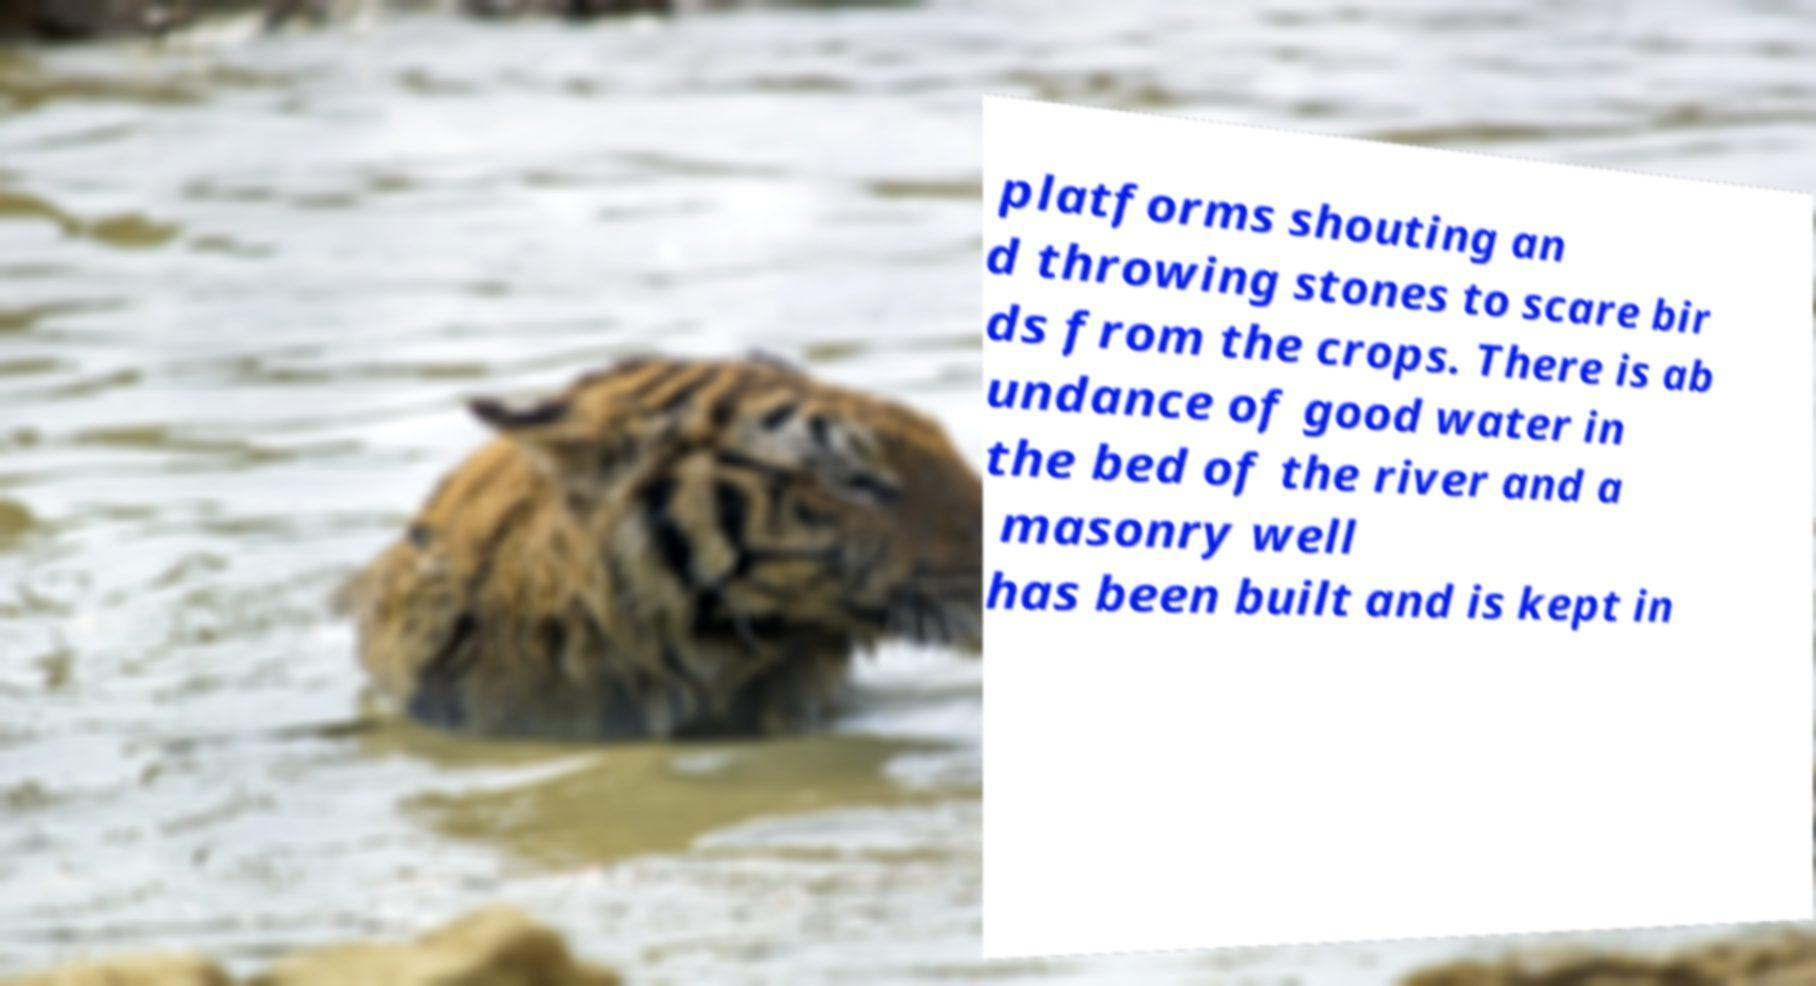There's text embedded in this image that I need extracted. Can you transcribe it verbatim? platforms shouting an d throwing stones to scare bir ds from the crops. There is ab undance of good water in the bed of the river and a masonry well has been built and is kept in 